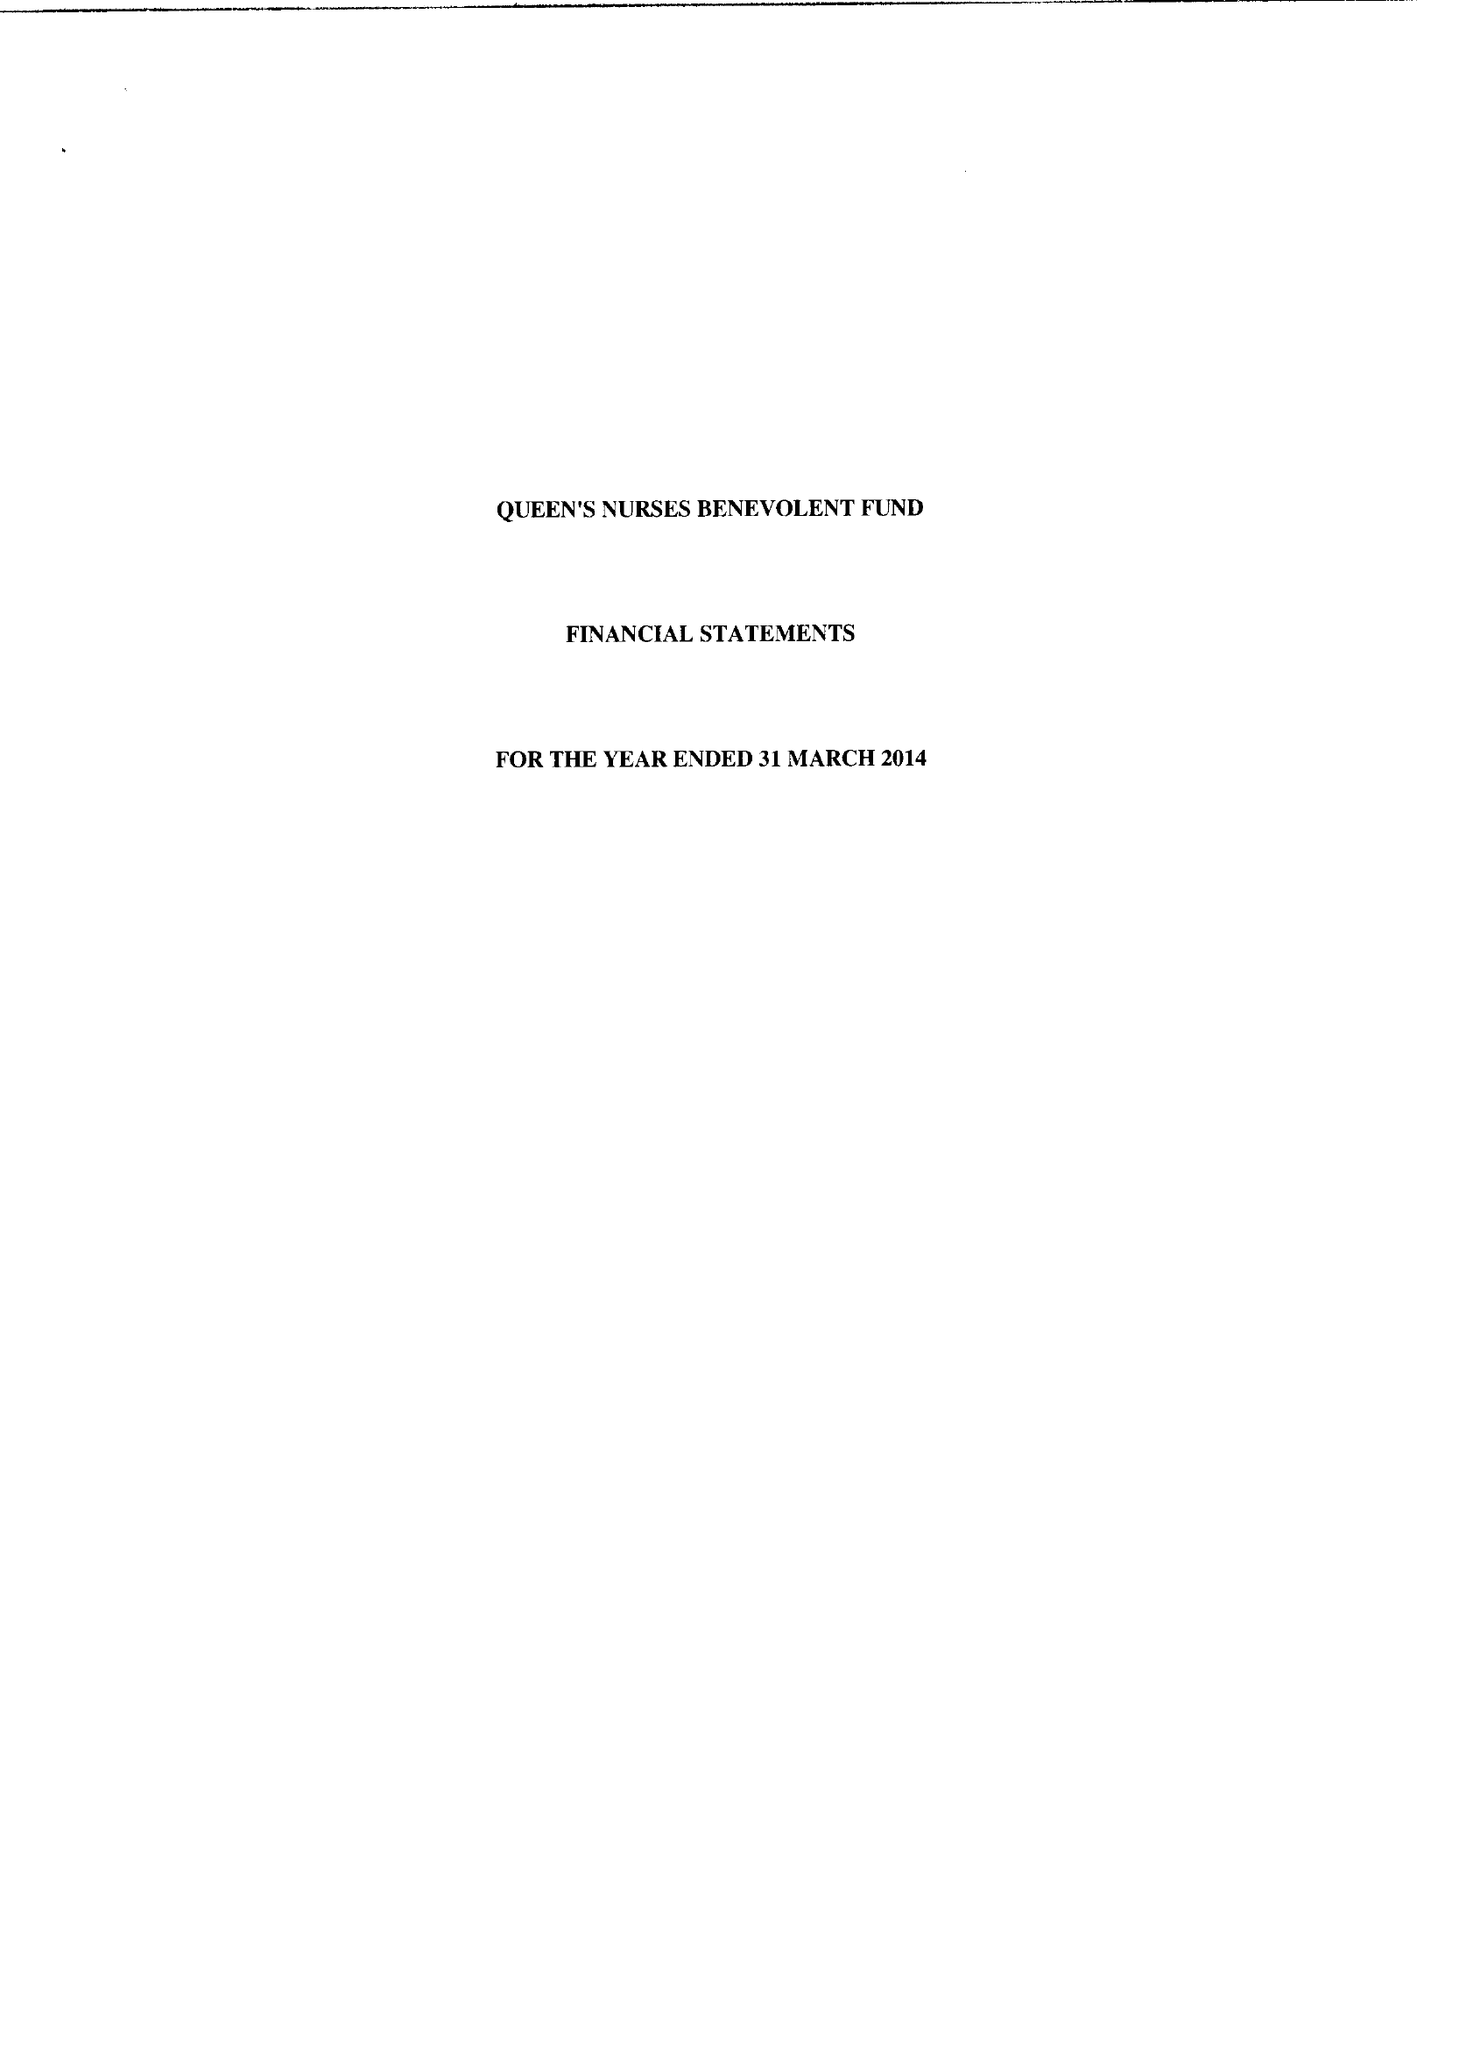What is the value for the address__post_town?
Answer the question using a single word or phrase. SUTTON 